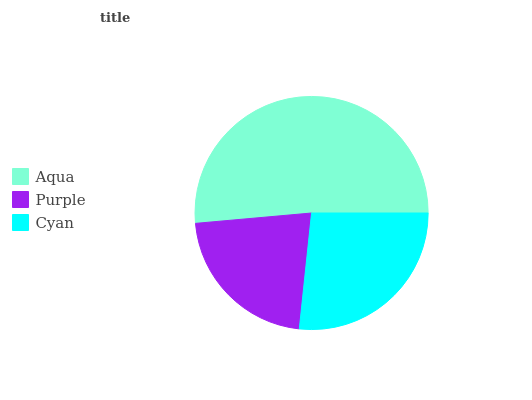Is Purple the minimum?
Answer yes or no. Yes. Is Aqua the maximum?
Answer yes or no. Yes. Is Cyan the minimum?
Answer yes or no. No. Is Cyan the maximum?
Answer yes or no. No. Is Cyan greater than Purple?
Answer yes or no. Yes. Is Purple less than Cyan?
Answer yes or no. Yes. Is Purple greater than Cyan?
Answer yes or no. No. Is Cyan less than Purple?
Answer yes or no. No. Is Cyan the high median?
Answer yes or no. Yes. Is Cyan the low median?
Answer yes or no. Yes. Is Aqua the high median?
Answer yes or no. No. Is Purple the low median?
Answer yes or no. No. 